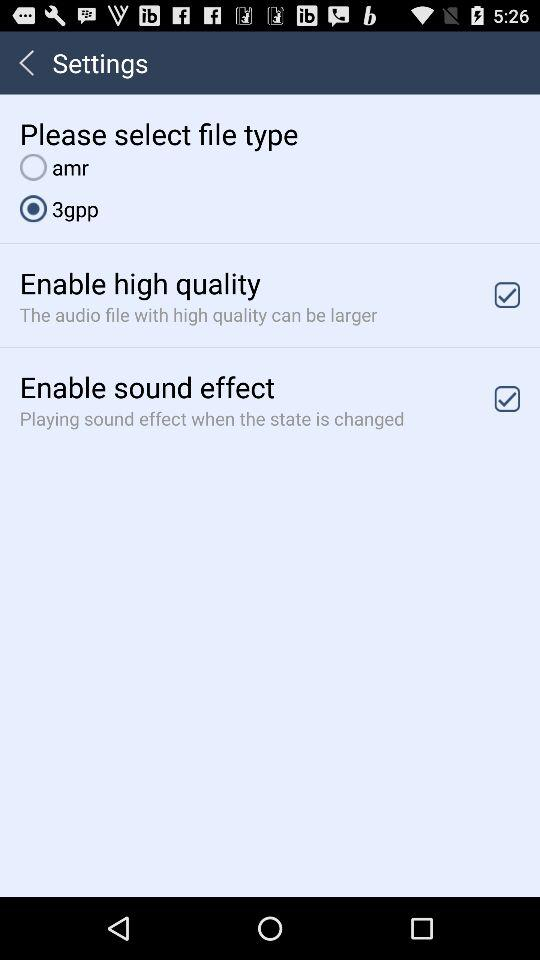What is the status of the "Enable sound effect"? The status of the "Enable sound effect" is "on". 